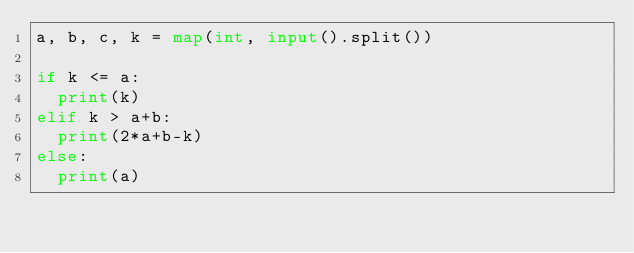<code> <loc_0><loc_0><loc_500><loc_500><_Python_>a, b, c, k = map(int, input().split())

if k <= a:
  print(k)
elif k > a+b:
  print(2*a+b-k)
else:
  print(a)
  </code> 